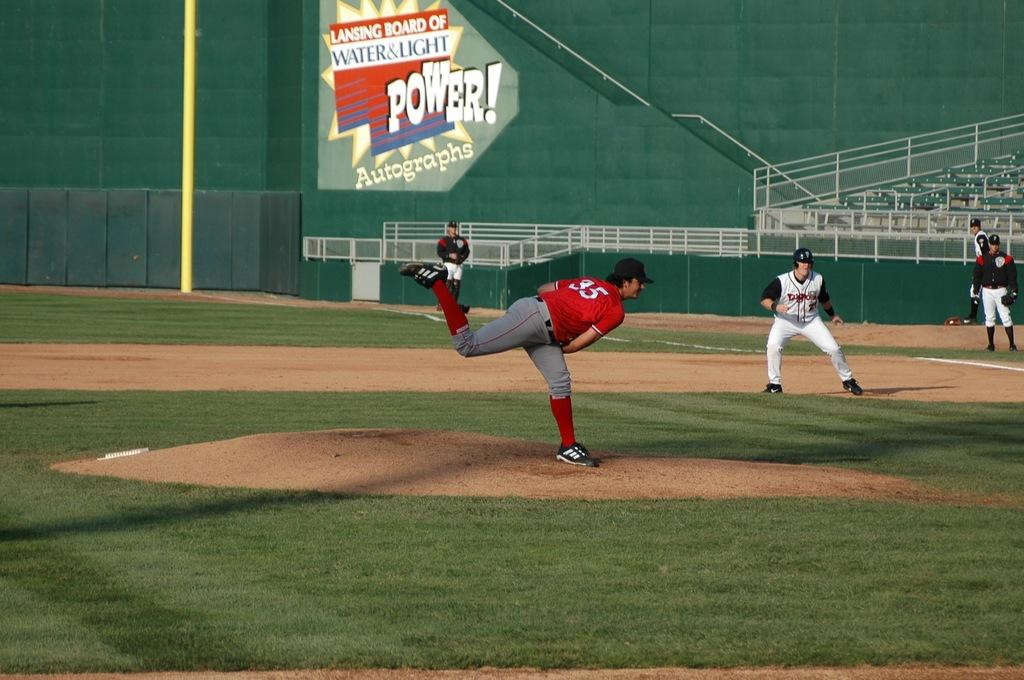<image>
Render a clear and concise summary of the photo. The pitcher in the baseball game is wearing an orange jersey with the number 35. 